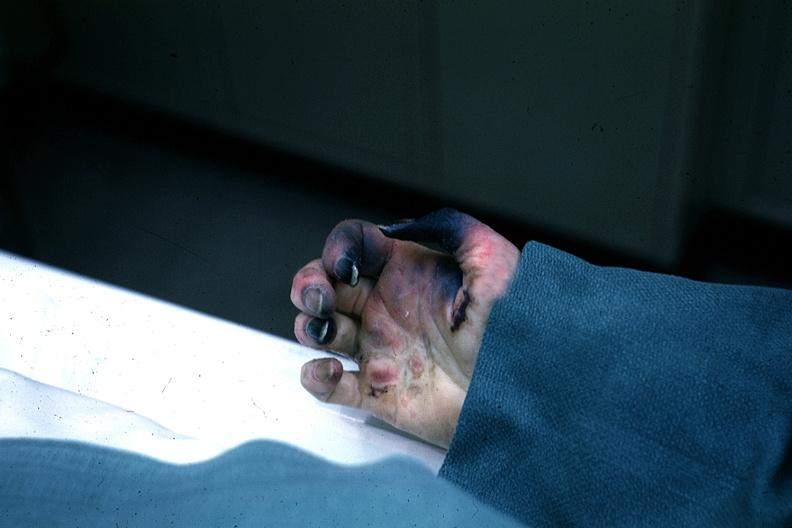does this image show excellent gangrenous necrosis of fingers said to be due to embolism?
Answer the question using a single word or phrase. Yes 